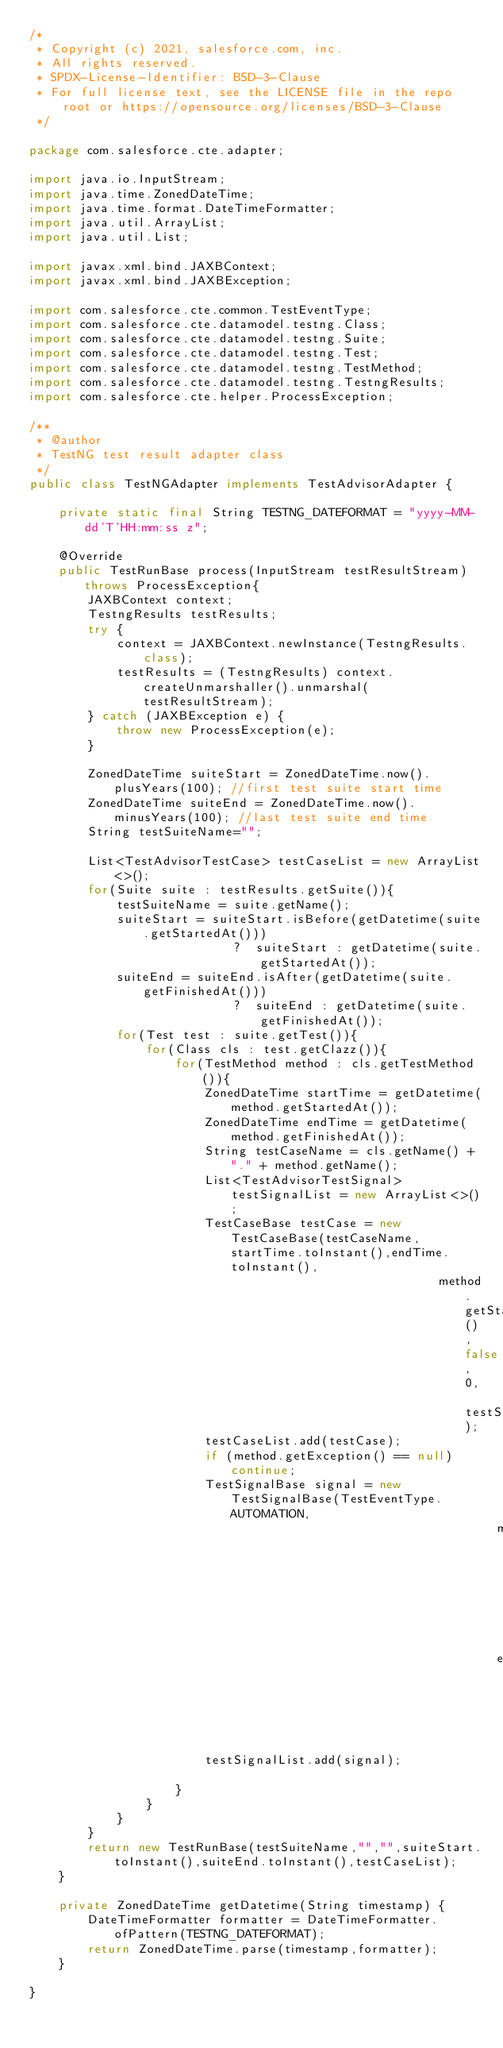<code> <loc_0><loc_0><loc_500><loc_500><_Java_>/*
 * Copyright (c) 2021, salesforce.com, inc.
 * All rights reserved.
 * SPDX-License-Identifier: BSD-3-Clause
 * For full license text, see the LICENSE file in the repo root or https://opensource.org/licenses/BSD-3-Clause
 */

package com.salesforce.cte.adapter;

import java.io.InputStream;
import java.time.ZonedDateTime;
import java.time.format.DateTimeFormatter;
import java.util.ArrayList;
import java.util.List;

import javax.xml.bind.JAXBContext;
import javax.xml.bind.JAXBException;

import com.salesforce.cte.common.TestEventType;
import com.salesforce.cte.datamodel.testng.Class;
import com.salesforce.cte.datamodel.testng.Suite;
import com.salesforce.cte.datamodel.testng.Test;
import com.salesforce.cte.datamodel.testng.TestMethod;
import com.salesforce.cte.datamodel.testng.TestngResults;
import com.salesforce.cte.helper.ProcessException;

/**
 * @author
 * TestNG test result adapter class
 */
public class TestNGAdapter implements TestAdvisorAdapter {

    private static final String TESTNG_DATEFORMAT = "yyyy-MM-dd'T'HH:mm:ss z";

    @Override
    public TestRunBase process(InputStream testResultStream) throws ProcessException{
        JAXBContext context;
        TestngResults testResults;
        try {
            context = JAXBContext.newInstance(TestngResults.class);
            testResults = (TestngResults) context.createUnmarshaller().unmarshal(testResultStream);
        } catch (JAXBException e) {
            throw new ProcessException(e);
        }

        ZonedDateTime suiteStart = ZonedDateTime.now().plusYears(100); //first test suite start time
        ZonedDateTime suiteEnd = ZonedDateTime.now().minusYears(100); //last test suite end time
        String testSuiteName="";

        List<TestAdvisorTestCase> testCaseList = new ArrayList<>();
        for(Suite suite : testResults.getSuite()){
            testSuiteName = suite.getName();
            suiteStart = suiteStart.isBefore(getDatetime(suite.getStartedAt())) 
                            ?  suiteStart : getDatetime(suite.getStartedAt());
            suiteEnd = suiteEnd.isAfter(getDatetime(suite.getFinishedAt())) 
                            ?  suiteEnd : getDatetime(suite.getFinishedAt());
            for(Test test : suite.getTest()){
                for(Class cls : test.getClazz()){
                    for(TestMethod method : cls.getTestMethod()){                      
                        ZonedDateTime startTime = getDatetime(method.getStartedAt());
                        ZonedDateTime endTime = getDatetime(method.getFinishedAt());
                        String testCaseName = cls.getName() + "." + method.getName();
                        List<TestAdvisorTestSignal> testSignalList = new ArrayList<>();
                        TestCaseBase testCase = new TestCaseBase(testCaseName,startTime.toInstant(),endTime.toInstant(),
                                                        method.getStatus(),false, 0, testSignalList);
                        testCaseList.add(testCase); 
                        if (method.getException() == null) continue;
                        TestSignalBase signal = new TestSignalBase(TestEventType.AUTOMATION,
                                                                method.getException().getClazz(),
                                                                endTime.toInstant());
                        testSignalList.add(signal);  
                        
                    }
                }
            }
        }
        return new TestRunBase(testSuiteName,"","",suiteStart.toInstant(),suiteEnd.toInstant(),testCaseList);
    }

    private ZonedDateTime getDatetime(String timestamp) {
        DateTimeFormatter formatter = DateTimeFormatter.ofPattern(TESTNG_DATEFORMAT);
        return ZonedDateTime.parse(timestamp,formatter);
    }
    
}
</code> 